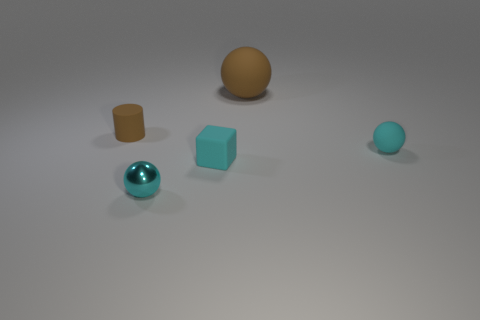Is there anything else that is the same shape as the tiny brown object?
Your answer should be very brief. No. How many matte things are the same color as the tiny rubber cylinder?
Your answer should be very brief. 1. How many other small cylinders have the same material as the tiny cylinder?
Provide a succinct answer. 0. What number of objects are either tiny cyan things or things that are to the left of the large brown sphere?
Offer a terse response. 4. What color is the small thing that is behind the matte sphere in front of the brown matte thing that is to the right of the metal ball?
Give a very brief answer. Brown. There is a matte sphere in front of the cylinder; what is its size?
Your answer should be compact. Small. What number of big objects are either brown things or cyan rubber things?
Ensure brevity in your answer.  1. What color is the rubber thing that is in front of the tiny brown rubber cylinder and on the right side of the cyan rubber cube?
Offer a very short reply. Cyan. Are there any other small things that have the same shape as the tiny cyan metal object?
Provide a succinct answer. Yes. What material is the tiny brown cylinder?
Offer a terse response. Rubber. 